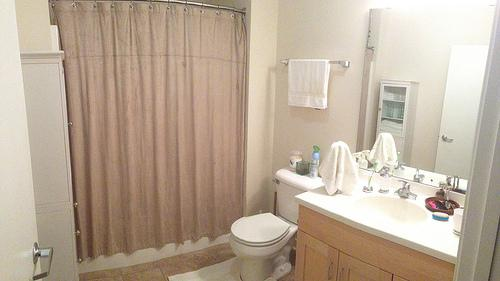Question: what type of flooring is in the picture?
Choices:
A. Wood.
B. Carpet.
C. Vinyl.
D. Tile.
Answer with the letter. Answer: D Question: what are the toiletries sitting on?
Choices:
A. A cabinet.
B. A table.
C. The counter.
D. The toilet.
Answer with the letter. Answer: C 